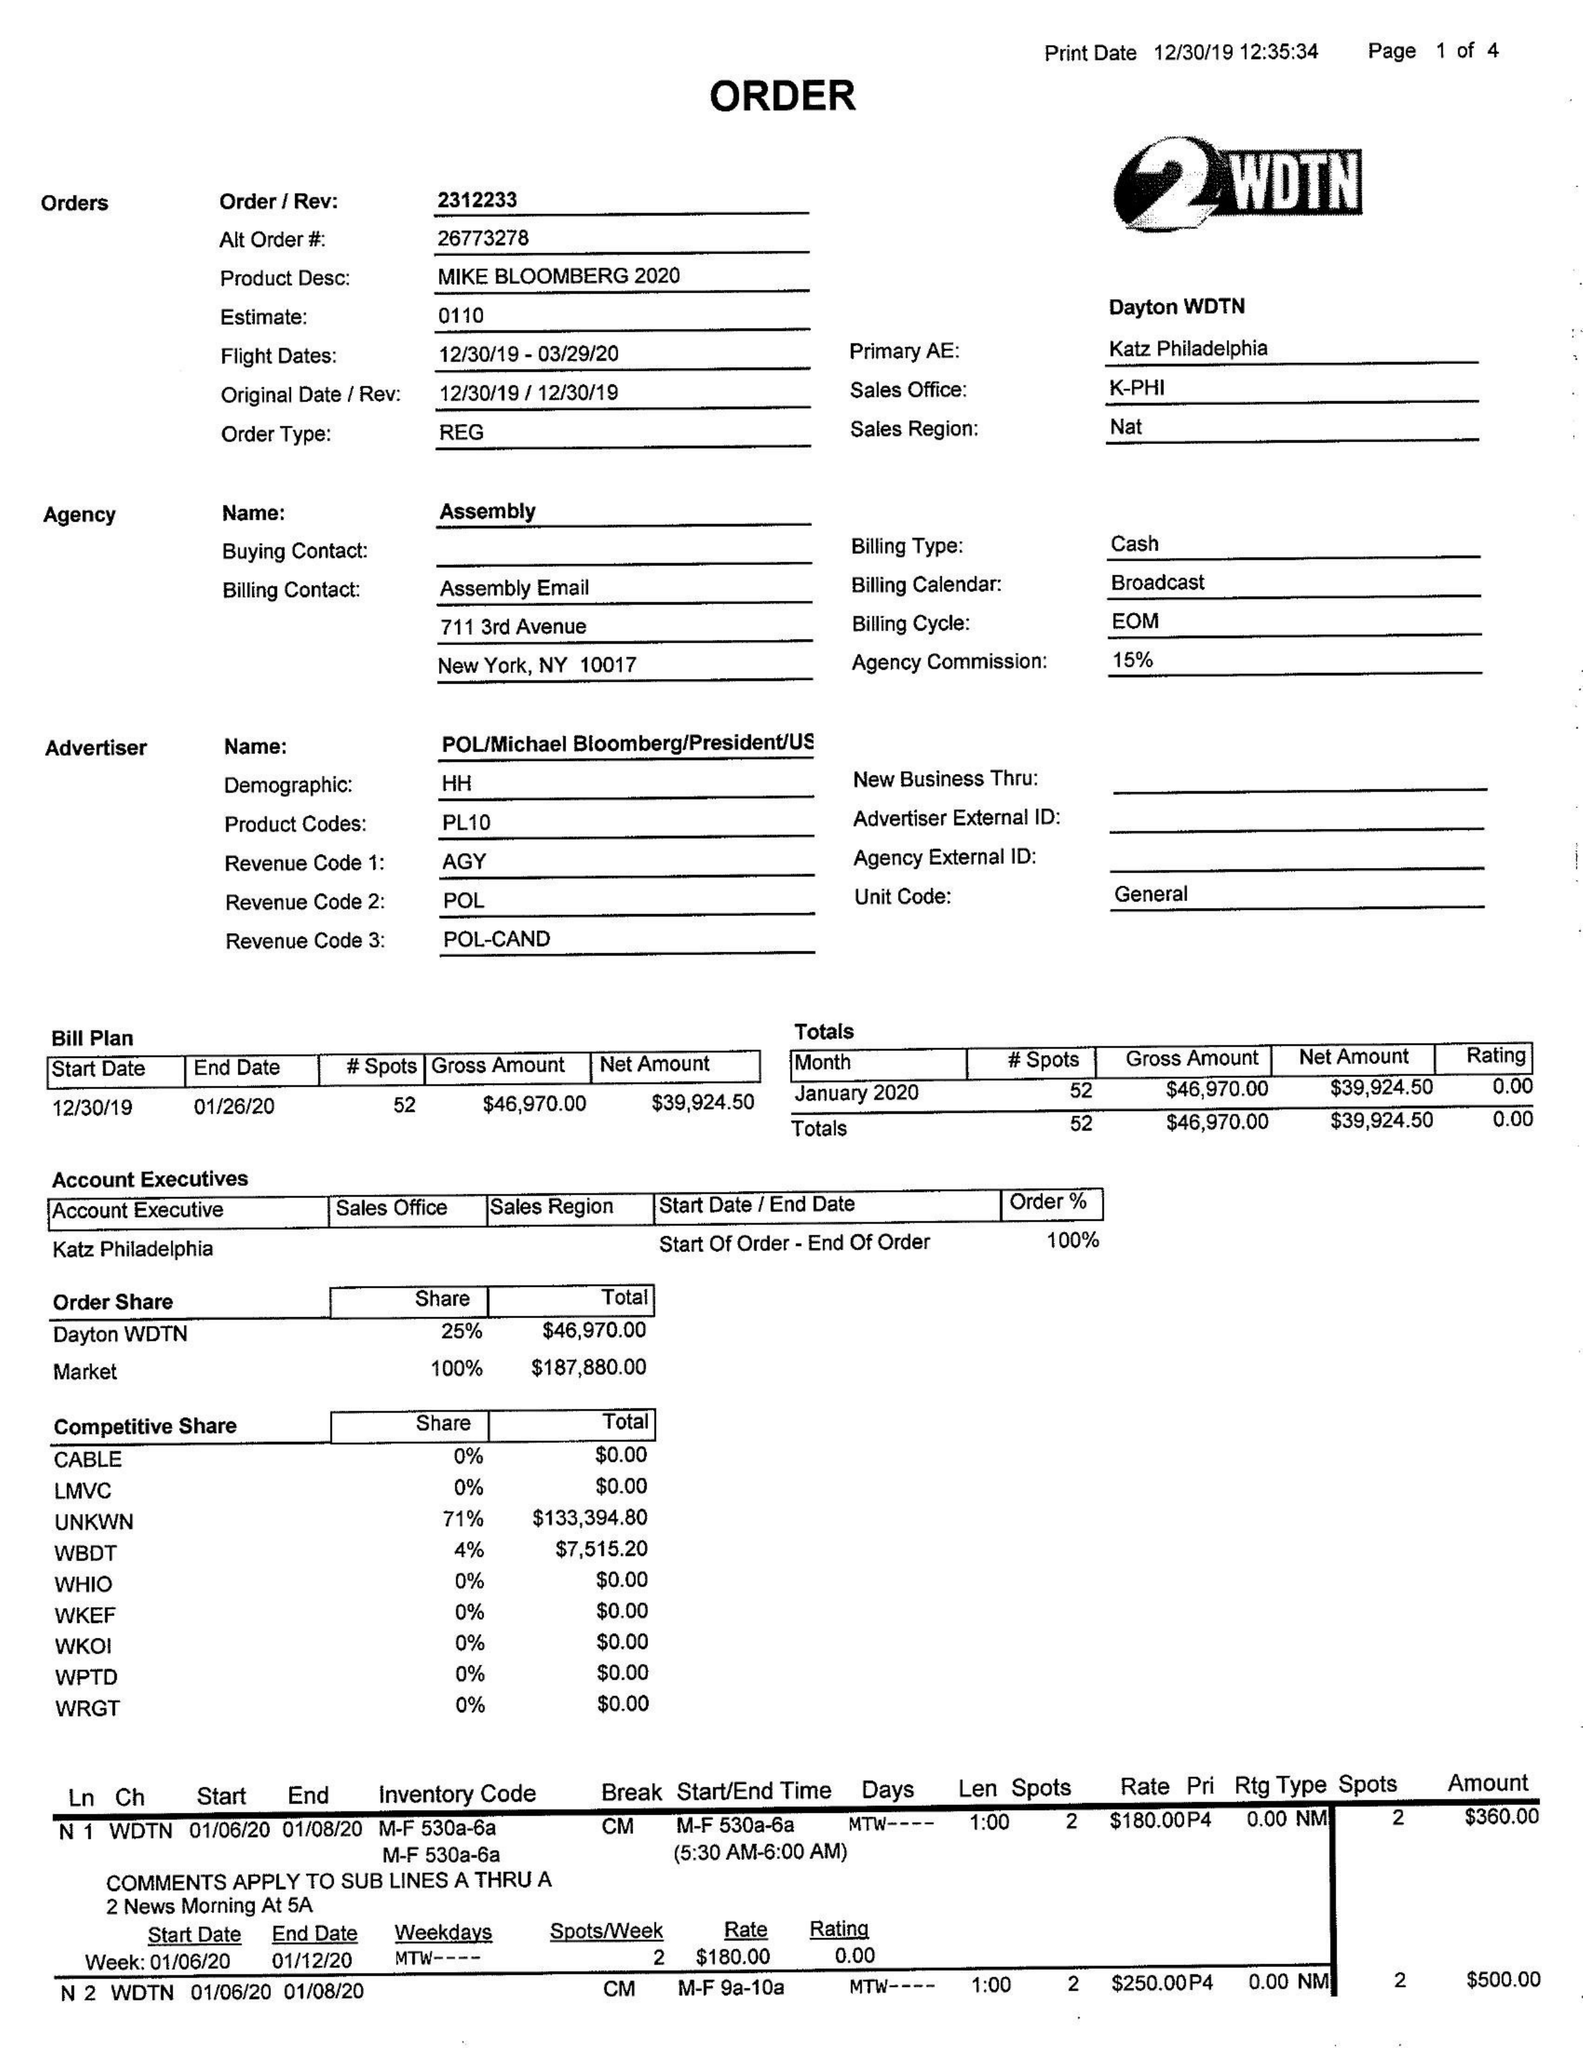What is the value for the advertiser?
Answer the question using a single word or phrase. POL/MICHAELBLOOMBERG/PRESIDENT/US 